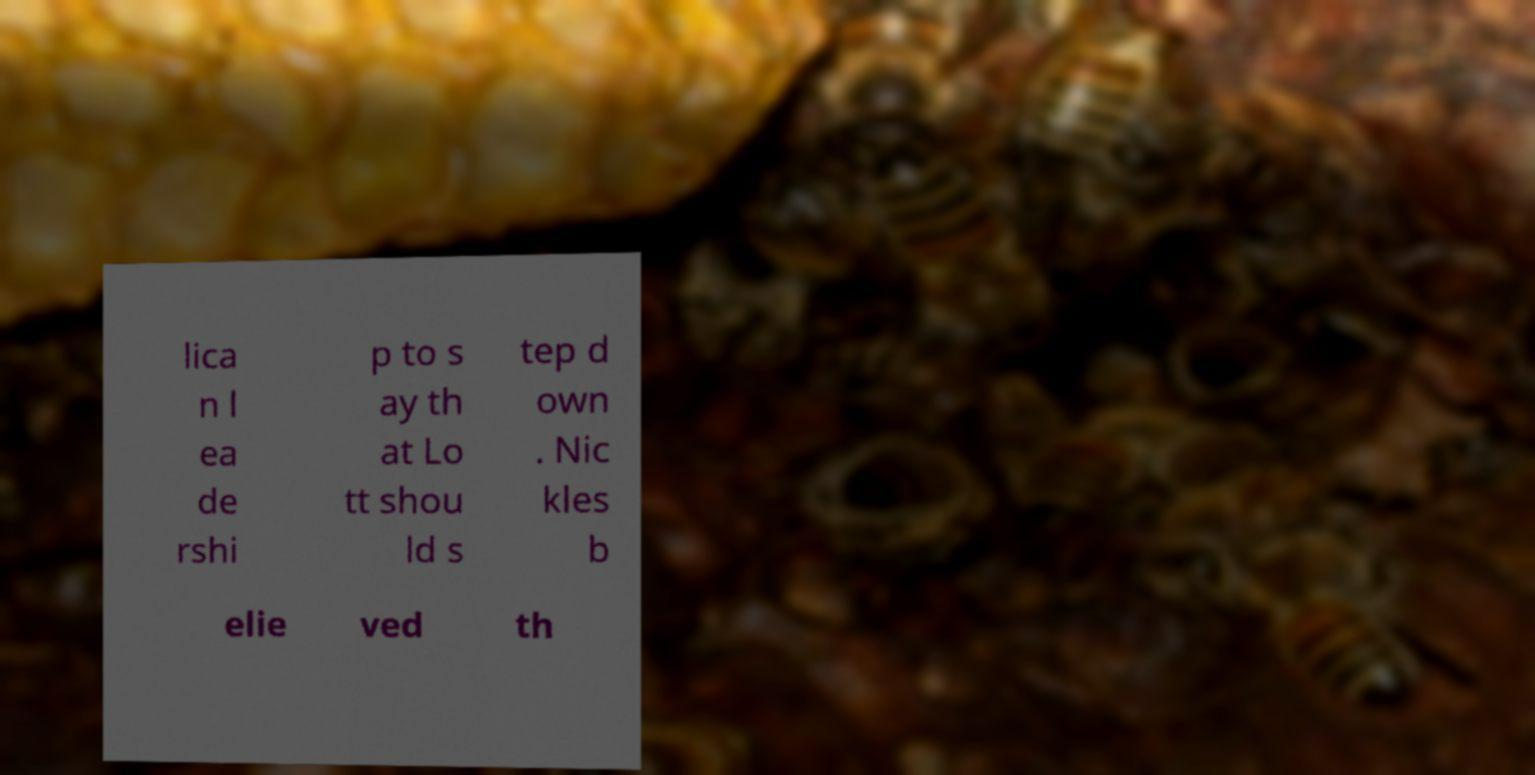Please read and relay the text visible in this image. What does it say? lica n l ea de rshi p to s ay th at Lo tt shou ld s tep d own . Nic kles b elie ved th 